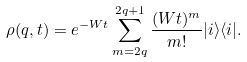<formula> <loc_0><loc_0><loc_500><loc_500>\rho ( q , t ) = e ^ { - W t } \sum _ { m = 2 q } ^ { 2 q + 1 } \frac { ( W t ) ^ { m } } { m ! } | i \rangle \langle i | .</formula> 